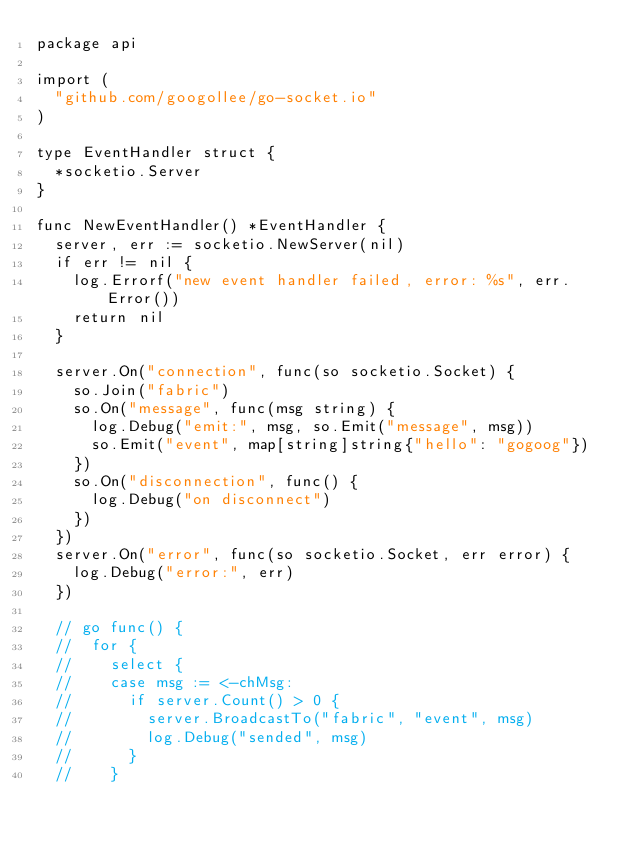Convert code to text. <code><loc_0><loc_0><loc_500><loc_500><_Go_>package api

import (
	"github.com/googollee/go-socket.io"
)

type EventHandler struct {
	*socketio.Server
}

func NewEventHandler() *EventHandler {
	server, err := socketio.NewServer(nil)
	if err != nil {
		log.Errorf("new event handler failed, error: %s", err.Error())
		return nil
	}

	server.On("connection", func(so socketio.Socket) {
		so.Join("fabric")
		so.On("message", func(msg string) {
			log.Debug("emit:", msg, so.Emit("message", msg))
			so.Emit("event", map[string]string{"hello": "gogoog"})
		})
		so.On("disconnection", func() {
			log.Debug("on disconnect")
		})
	})
	server.On("error", func(so socketio.Socket, err error) {
		log.Debug("error:", err)
	})

	// go func() {
	// 	for {
	// 		select {
	// 		case msg := <-chMsg:
	// 			if server.Count() > 0 {
	// 				server.BroadcastTo("fabric", "event", msg)
	// 				log.Debug("sended", msg)
	// 			}
	// 		}</code> 